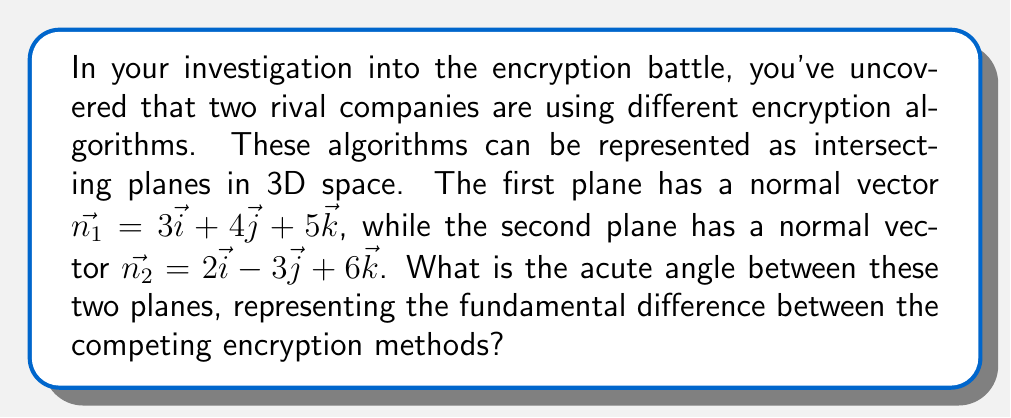Help me with this question. To find the angle between two intersecting planes, we can use the dot product of their normal vectors. The formula for the angle $\theta$ between two planes with normal vectors $\vec{n_1}$ and $\vec{n_2}$ is:

$$\cos \theta = \frac{|\vec{n_1} \cdot \vec{n_2}|}{\|\vec{n_1}\| \|\vec{n_2}\|}$$

Let's solve this step by step:

1) First, calculate the dot product $\vec{n_1} \cdot \vec{n_2}$:
   $\vec{n_1} \cdot \vec{n_2} = (3)(2) + (4)(-3) + (5)(6) = 6 - 12 + 30 = 24$

2) Calculate the magnitudes of $\vec{n_1}$ and $\vec{n_2}$:
   $\|\vec{n_1}\| = \sqrt{3^2 + 4^2 + 5^2} = \sqrt{9 + 16 + 25} = \sqrt{50}$
   $\|\vec{n_2}\| = \sqrt{2^2 + (-3)^2 + 6^2} = \sqrt{4 + 9 + 36} = \sqrt{49} = 7$

3) Now, substitute these values into the formula:
   $$\cos \theta = \frac{|24|}{\sqrt{50} \cdot 7} = \frac{24}{\sqrt{50} \cdot 7}$$

4) Simplify:
   $$\cos \theta = \frac{24}{7\sqrt{50}} = \frac{24\sqrt{2}}{70}$$

5) To find $\theta$, take the inverse cosine (arccos) of both sides:
   $$\theta = \arccos\left(\frac{24\sqrt{2}}{70}\right)$$

6) Using a calculator, we can evaluate this to get the angle in radians, then convert to degrees:
   $\theta \approx 0.7854$ radians $\approx 45.00°$

Thus, the acute angle between the two planes is approximately 45.00°.
Answer: $45.00°$ 